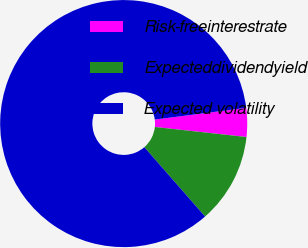Convert chart. <chart><loc_0><loc_0><loc_500><loc_500><pie_chart><fcel>Risk-freeinterestrate<fcel>Expecteddividendyield<fcel>Expected volatility<nl><fcel>3.77%<fcel>11.82%<fcel>84.42%<nl></chart> 